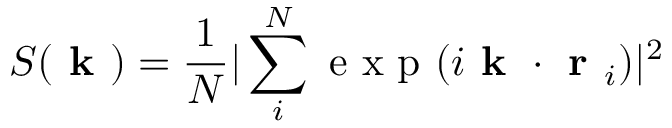<formula> <loc_0><loc_0><loc_500><loc_500>S ( k ) = \frac { 1 } { N } | \sum _ { i } ^ { N } e x p ( i k \cdot r _ { i } ) | ^ { 2 }</formula> 